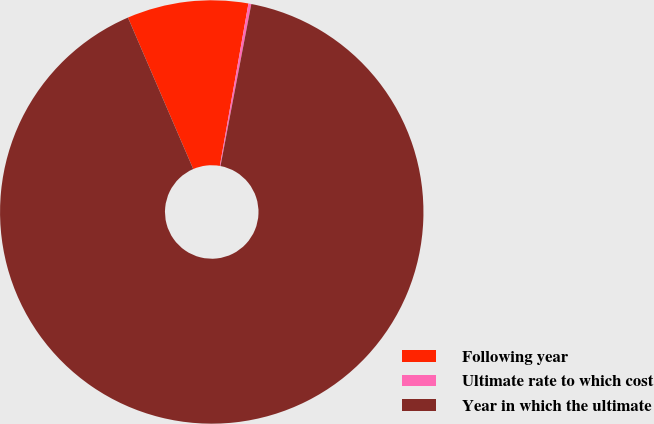Convert chart to OTSL. <chart><loc_0><loc_0><loc_500><loc_500><pie_chart><fcel>Following year<fcel>Ultimate rate to which cost<fcel>Year in which the ultimate<nl><fcel>9.25%<fcel>0.22%<fcel>90.52%<nl></chart> 